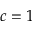<formula> <loc_0><loc_0><loc_500><loc_500>c = 1</formula> 